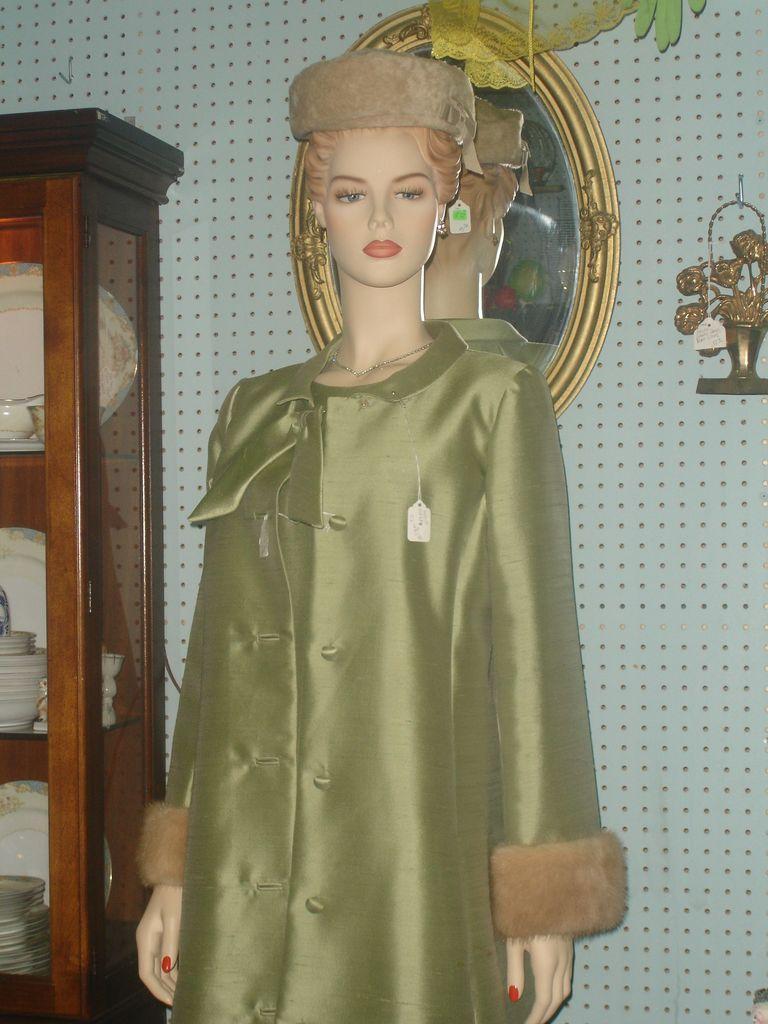How would you summarize this image in a sentence or two? In this picture we can see the statue wearing green gown standing in the front. Behind you can see the wooden wardrobe with white color crockery inside. Behind there is a wall and golden mirror. 